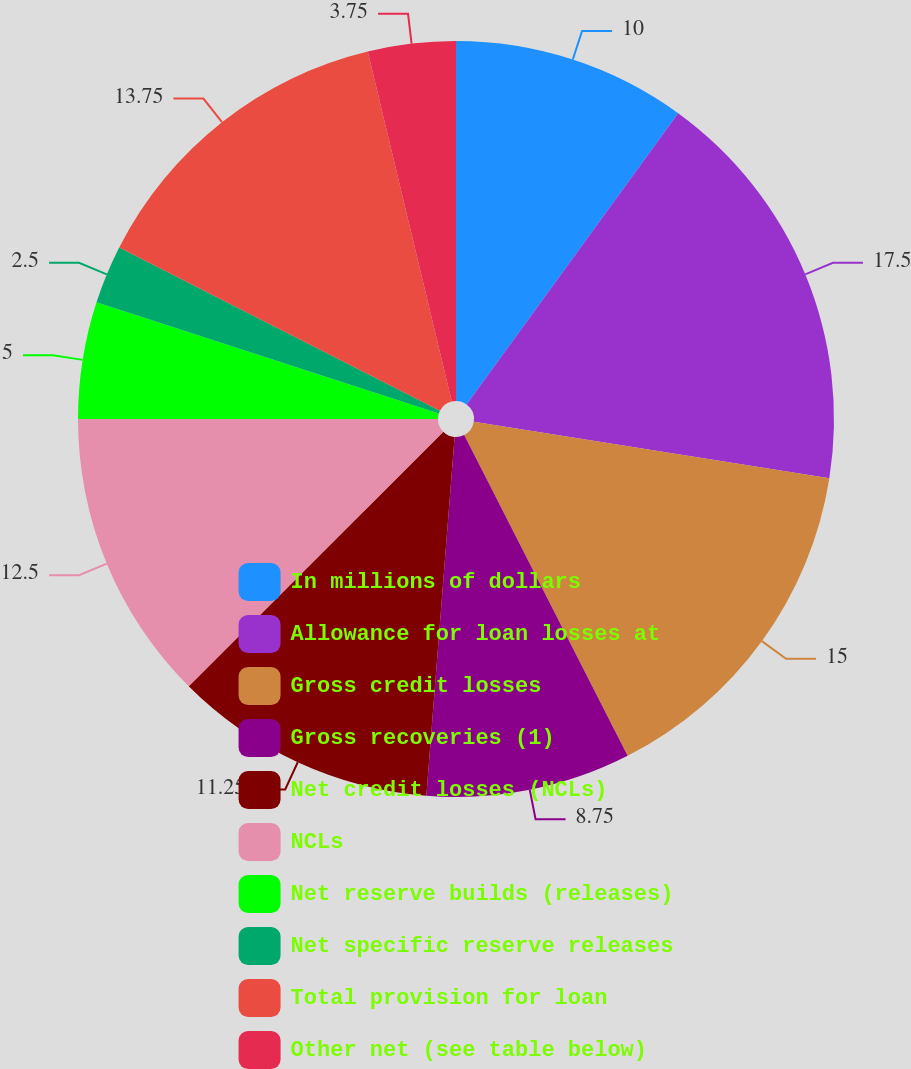<chart> <loc_0><loc_0><loc_500><loc_500><pie_chart><fcel>In millions of dollars<fcel>Allowance for loan losses at<fcel>Gross credit losses<fcel>Gross recoveries (1)<fcel>Net credit losses (NCLs)<fcel>NCLs<fcel>Net reserve builds (releases)<fcel>Net specific reserve releases<fcel>Total provision for loan<fcel>Other net (see table below)<nl><fcel>10.0%<fcel>17.5%<fcel>15.0%<fcel>8.75%<fcel>11.25%<fcel>12.5%<fcel>5.0%<fcel>2.5%<fcel>13.75%<fcel>3.75%<nl></chart> 